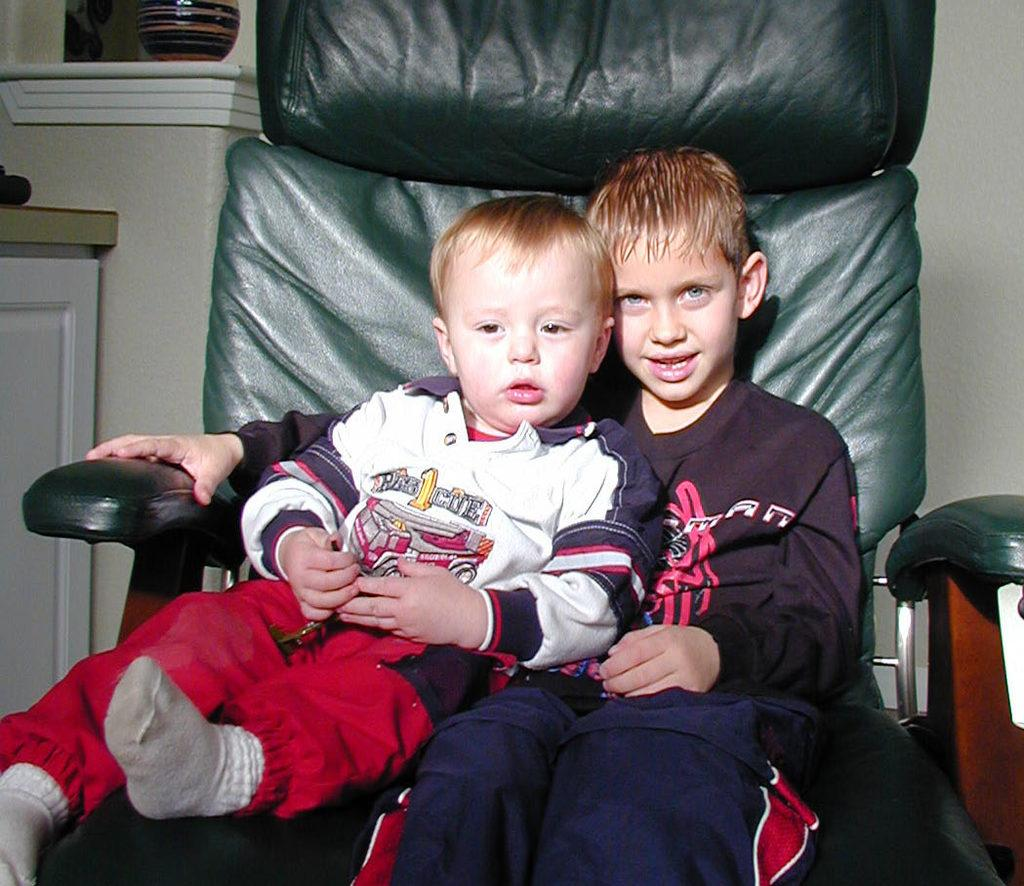How many people are in the image? There are two boys in the image. What are the boys doing in the image? The boys are sitting on a chair. What can be seen in the background of the image? There is a wall and a desk in the background of the image. What is the name of the society that the boys belong to in the image? There is no information about a society or any names in the image. 